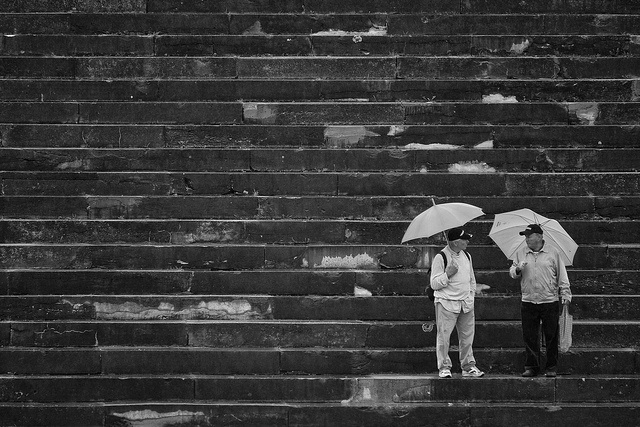Describe the objects in this image and their specific colors. I can see people in black, darkgray, gray, and lightgray tones, people in black, darkgray, gray, and lightgray tones, umbrella in black, darkgray, lightgray, and gray tones, umbrella in black, darkgray, lightgray, and gray tones, and backpack in black, gray, and darkgray tones in this image. 